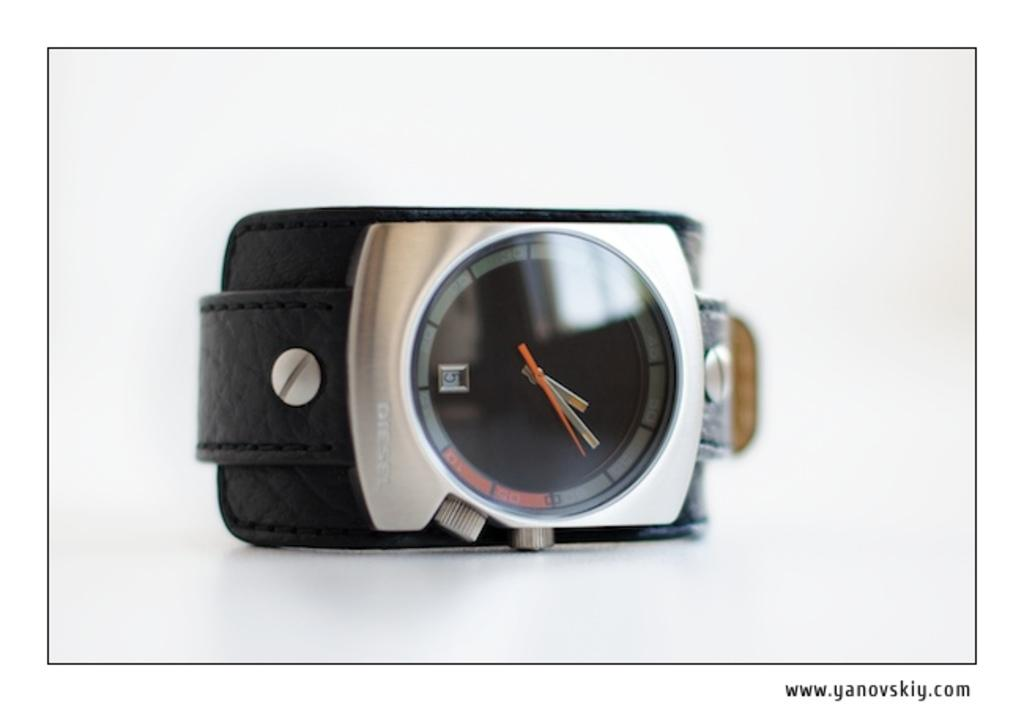What type of object is present in the image that is used for telling time? There is a watch in the image. How many time-telling objects can be seen in the image? There are two watches or clocks in the image. What type of accessory is visible in the image? There is a leather belt in the image. Where is the text located in the image? The text is at the bottom right of the image. What type of bells can be heard ringing in the image? There are no bells present in the image, and therefore no sounds can be heard. What type of mark is visible on the leather belt in the image? There is no mention of a mark on the leather belt in the provided facts, so it cannot be determined from the image. 